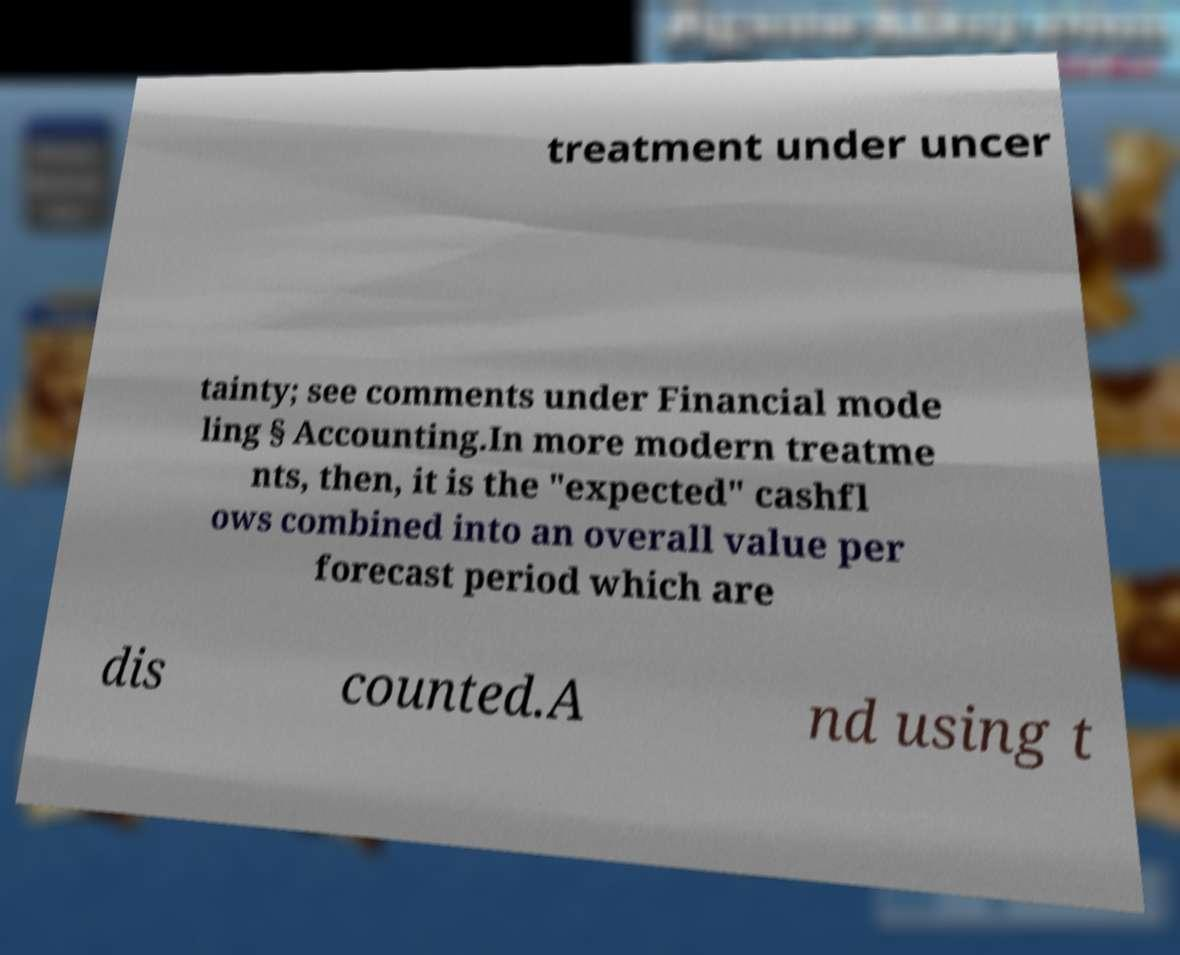Can you accurately transcribe the text from the provided image for me? treatment under uncer tainty; see comments under Financial mode ling § Accounting.In more modern treatme nts, then, it is the "expected" cashfl ows combined into an overall value per forecast period which are dis counted.A nd using t 